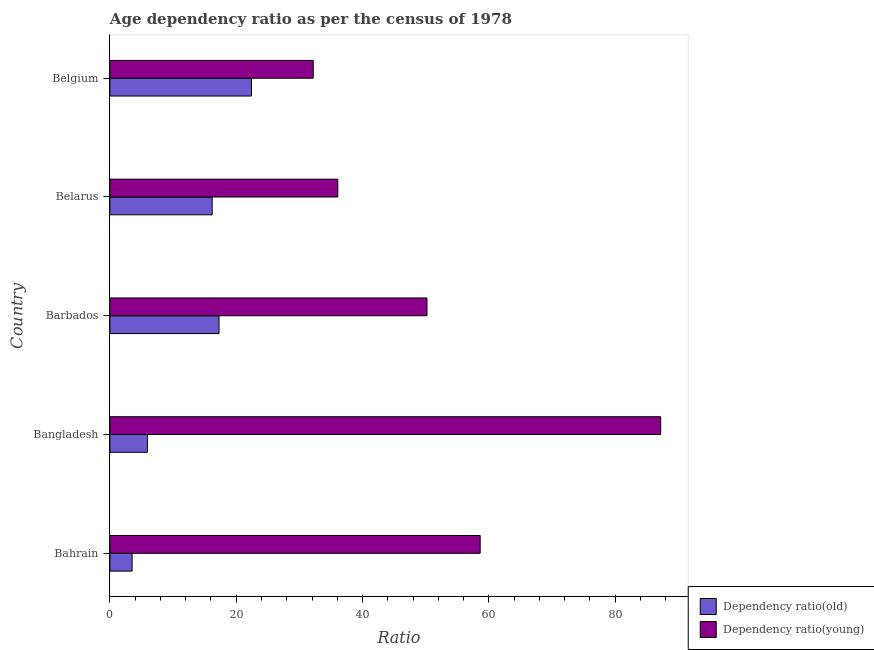Are the number of bars per tick equal to the number of legend labels?
Provide a short and direct response. Yes. Are the number of bars on each tick of the Y-axis equal?
Your answer should be very brief. Yes. What is the label of the 3rd group of bars from the top?
Provide a succinct answer. Barbados. In how many cases, is the number of bars for a given country not equal to the number of legend labels?
Your response must be concise. 0. What is the age dependency ratio(young) in Belarus?
Make the answer very short. 36.09. Across all countries, what is the maximum age dependency ratio(young)?
Keep it short and to the point. 87.21. Across all countries, what is the minimum age dependency ratio(old)?
Offer a very short reply. 3.52. In which country was the age dependency ratio(old) maximum?
Make the answer very short. Belgium. In which country was the age dependency ratio(young) minimum?
Your answer should be very brief. Belgium. What is the total age dependency ratio(young) in the graph?
Provide a short and direct response. 264.32. What is the difference between the age dependency ratio(old) in Barbados and that in Belgium?
Offer a terse response. -5.14. What is the difference between the age dependency ratio(young) in Bangladesh and the age dependency ratio(old) in Belgium?
Your response must be concise. 64.79. What is the average age dependency ratio(old) per country?
Make the answer very short. 13.07. What is the difference between the age dependency ratio(old) and age dependency ratio(young) in Bahrain?
Provide a short and direct response. -55.11. What is the ratio of the age dependency ratio(young) in Bahrain to that in Belgium?
Give a very brief answer. 1.82. Is the age dependency ratio(young) in Bahrain less than that in Belarus?
Make the answer very short. No. Is the difference between the age dependency ratio(young) in Bahrain and Belgium greater than the difference between the age dependency ratio(old) in Bahrain and Belgium?
Ensure brevity in your answer.  Yes. What is the difference between the highest and the second highest age dependency ratio(old)?
Keep it short and to the point. 5.14. What is the difference between the highest and the lowest age dependency ratio(young)?
Ensure brevity in your answer.  55.01. Is the sum of the age dependency ratio(old) in Bangladesh and Belarus greater than the maximum age dependency ratio(young) across all countries?
Your response must be concise. No. What does the 1st bar from the top in Barbados represents?
Offer a terse response. Dependency ratio(young). What does the 1st bar from the bottom in Bangladesh represents?
Ensure brevity in your answer.  Dependency ratio(old). How many bars are there?
Make the answer very short. 10. Are the values on the major ticks of X-axis written in scientific E-notation?
Provide a succinct answer. No. Does the graph contain grids?
Ensure brevity in your answer.  No. How are the legend labels stacked?
Your answer should be compact. Vertical. What is the title of the graph?
Make the answer very short. Age dependency ratio as per the census of 1978. Does "Short-term debt" appear as one of the legend labels in the graph?
Your answer should be compact. No. What is the label or title of the X-axis?
Offer a terse response. Ratio. What is the label or title of the Y-axis?
Provide a succinct answer. Country. What is the Ratio of Dependency ratio(old) in Bahrain?
Your response must be concise. 3.52. What is the Ratio in Dependency ratio(young) in Bahrain?
Your answer should be compact. 58.62. What is the Ratio of Dependency ratio(old) in Bangladesh?
Make the answer very short. 5.94. What is the Ratio in Dependency ratio(young) in Bangladesh?
Offer a very short reply. 87.21. What is the Ratio of Dependency ratio(old) in Barbados?
Offer a very short reply. 17.28. What is the Ratio of Dependency ratio(young) in Barbados?
Make the answer very short. 50.21. What is the Ratio in Dependency ratio(old) in Belarus?
Ensure brevity in your answer.  16.19. What is the Ratio in Dependency ratio(young) in Belarus?
Offer a terse response. 36.09. What is the Ratio in Dependency ratio(old) in Belgium?
Your answer should be compact. 22.42. What is the Ratio of Dependency ratio(young) in Belgium?
Provide a succinct answer. 32.19. Across all countries, what is the maximum Ratio in Dependency ratio(old)?
Your answer should be very brief. 22.42. Across all countries, what is the maximum Ratio of Dependency ratio(young)?
Offer a very short reply. 87.21. Across all countries, what is the minimum Ratio of Dependency ratio(old)?
Provide a short and direct response. 3.52. Across all countries, what is the minimum Ratio in Dependency ratio(young)?
Offer a very short reply. 32.19. What is the total Ratio in Dependency ratio(old) in the graph?
Keep it short and to the point. 65.34. What is the total Ratio in Dependency ratio(young) in the graph?
Give a very brief answer. 264.32. What is the difference between the Ratio in Dependency ratio(old) in Bahrain and that in Bangladesh?
Give a very brief answer. -2.42. What is the difference between the Ratio in Dependency ratio(young) in Bahrain and that in Bangladesh?
Offer a very short reply. -28.58. What is the difference between the Ratio of Dependency ratio(old) in Bahrain and that in Barbados?
Your answer should be very brief. -13.76. What is the difference between the Ratio in Dependency ratio(young) in Bahrain and that in Barbados?
Provide a succinct answer. 8.42. What is the difference between the Ratio of Dependency ratio(old) in Bahrain and that in Belarus?
Make the answer very short. -12.67. What is the difference between the Ratio in Dependency ratio(young) in Bahrain and that in Belarus?
Keep it short and to the point. 22.54. What is the difference between the Ratio in Dependency ratio(old) in Bahrain and that in Belgium?
Offer a very short reply. -18.9. What is the difference between the Ratio in Dependency ratio(young) in Bahrain and that in Belgium?
Provide a succinct answer. 26.43. What is the difference between the Ratio in Dependency ratio(old) in Bangladesh and that in Barbados?
Ensure brevity in your answer.  -11.34. What is the difference between the Ratio of Dependency ratio(young) in Bangladesh and that in Barbados?
Offer a very short reply. 37. What is the difference between the Ratio of Dependency ratio(old) in Bangladesh and that in Belarus?
Offer a terse response. -10.25. What is the difference between the Ratio of Dependency ratio(young) in Bangladesh and that in Belarus?
Ensure brevity in your answer.  51.12. What is the difference between the Ratio in Dependency ratio(old) in Bangladesh and that in Belgium?
Offer a very short reply. -16.48. What is the difference between the Ratio of Dependency ratio(young) in Bangladesh and that in Belgium?
Your answer should be very brief. 55.01. What is the difference between the Ratio in Dependency ratio(old) in Barbados and that in Belarus?
Your answer should be very brief. 1.09. What is the difference between the Ratio in Dependency ratio(young) in Barbados and that in Belarus?
Your answer should be compact. 14.12. What is the difference between the Ratio of Dependency ratio(old) in Barbados and that in Belgium?
Make the answer very short. -5.14. What is the difference between the Ratio in Dependency ratio(young) in Barbados and that in Belgium?
Provide a succinct answer. 18.01. What is the difference between the Ratio in Dependency ratio(old) in Belarus and that in Belgium?
Provide a short and direct response. -6.22. What is the difference between the Ratio in Dependency ratio(young) in Belarus and that in Belgium?
Provide a succinct answer. 3.89. What is the difference between the Ratio in Dependency ratio(old) in Bahrain and the Ratio in Dependency ratio(young) in Bangladesh?
Make the answer very short. -83.69. What is the difference between the Ratio in Dependency ratio(old) in Bahrain and the Ratio in Dependency ratio(young) in Barbados?
Keep it short and to the point. -46.69. What is the difference between the Ratio of Dependency ratio(old) in Bahrain and the Ratio of Dependency ratio(young) in Belarus?
Keep it short and to the point. -32.57. What is the difference between the Ratio in Dependency ratio(old) in Bahrain and the Ratio in Dependency ratio(young) in Belgium?
Make the answer very short. -28.68. What is the difference between the Ratio in Dependency ratio(old) in Bangladesh and the Ratio in Dependency ratio(young) in Barbados?
Keep it short and to the point. -44.27. What is the difference between the Ratio of Dependency ratio(old) in Bangladesh and the Ratio of Dependency ratio(young) in Belarus?
Offer a terse response. -30.15. What is the difference between the Ratio in Dependency ratio(old) in Bangladesh and the Ratio in Dependency ratio(young) in Belgium?
Offer a very short reply. -26.26. What is the difference between the Ratio of Dependency ratio(old) in Barbados and the Ratio of Dependency ratio(young) in Belarus?
Provide a short and direct response. -18.81. What is the difference between the Ratio in Dependency ratio(old) in Barbados and the Ratio in Dependency ratio(young) in Belgium?
Your answer should be compact. -14.92. What is the difference between the Ratio of Dependency ratio(old) in Belarus and the Ratio of Dependency ratio(young) in Belgium?
Offer a very short reply. -16. What is the average Ratio of Dependency ratio(old) per country?
Give a very brief answer. 13.07. What is the average Ratio in Dependency ratio(young) per country?
Offer a terse response. 52.86. What is the difference between the Ratio in Dependency ratio(old) and Ratio in Dependency ratio(young) in Bahrain?
Offer a very short reply. -55.11. What is the difference between the Ratio of Dependency ratio(old) and Ratio of Dependency ratio(young) in Bangladesh?
Offer a terse response. -81.27. What is the difference between the Ratio of Dependency ratio(old) and Ratio of Dependency ratio(young) in Barbados?
Ensure brevity in your answer.  -32.93. What is the difference between the Ratio in Dependency ratio(old) and Ratio in Dependency ratio(young) in Belarus?
Offer a very short reply. -19.89. What is the difference between the Ratio of Dependency ratio(old) and Ratio of Dependency ratio(young) in Belgium?
Offer a terse response. -9.78. What is the ratio of the Ratio of Dependency ratio(old) in Bahrain to that in Bangladesh?
Provide a short and direct response. 0.59. What is the ratio of the Ratio of Dependency ratio(young) in Bahrain to that in Bangladesh?
Your response must be concise. 0.67. What is the ratio of the Ratio of Dependency ratio(old) in Bahrain to that in Barbados?
Your answer should be compact. 0.2. What is the ratio of the Ratio of Dependency ratio(young) in Bahrain to that in Barbados?
Provide a short and direct response. 1.17. What is the ratio of the Ratio in Dependency ratio(old) in Bahrain to that in Belarus?
Provide a succinct answer. 0.22. What is the ratio of the Ratio in Dependency ratio(young) in Bahrain to that in Belarus?
Keep it short and to the point. 1.62. What is the ratio of the Ratio of Dependency ratio(old) in Bahrain to that in Belgium?
Your response must be concise. 0.16. What is the ratio of the Ratio in Dependency ratio(young) in Bahrain to that in Belgium?
Your response must be concise. 1.82. What is the ratio of the Ratio in Dependency ratio(old) in Bangladesh to that in Barbados?
Offer a terse response. 0.34. What is the ratio of the Ratio in Dependency ratio(young) in Bangladesh to that in Barbados?
Offer a terse response. 1.74. What is the ratio of the Ratio of Dependency ratio(old) in Bangladesh to that in Belarus?
Your response must be concise. 0.37. What is the ratio of the Ratio of Dependency ratio(young) in Bangladesh to that in Belarus?
Your answer should be compact. 2.42. What is the ratio of the Ratio of Dependency ratio(old) in Bangladesh to that in Belgium?
Give a very brief answer. 0.27. What is the ratio of the Ratio of Dependency ratio(young) in Bangladesh to that in Belgium?
Your answer should be compact. 2.71. What is the ratio of the Ratio of Dependency ratio(old) in Barbados to that in Belarus?
Your response must be concise. 1.07. What is the ratio of the Ratio of Dependency ratio(young) in Barbados to that in Belarus?
Offer a terse response. 1.39. What is the ratio of the Ratio in Dependency ratio(old) in Barbados to that in Belgium?
Provide a succinct answer. 0.77. What is the ratio of the Ratio in Dependency ratio(young) in Barbados to that in Belgium?
Provide a succinct answer. 1.56. What is the ratio of the Ratio in Dependency ratio(old) in Belarus to that in Belgium?
Provide a succinct answer. 0.72. What is the ratio of the Ratio in Dependency ratio(young) in Belarus to that in Belgium?
Keep it short and to the point. 1.12. What is the difference between the highest and the second highest Ratio in Dependency ratio(old)?
Your answer should be compact. 5.14. What is the difference between the highest and the second highest Ratio of Dependency ratio(young)?
Make the answer very short. 28.58. What is the difference between the highest and the lowest Ratio of Dependency ratio(old)?
Offer a terse response. 18.9. What is the difference between the highest and the lowest Ratio in Dependency ratio(young)?
Provide a short and direct response. 55.01. 